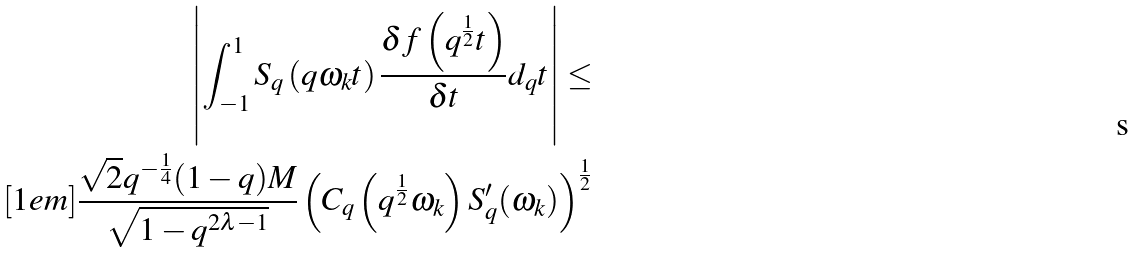Convert formula to latex. <formula><loc_0><loc_0><loc_500><loc_500>\left | \int _ { - 1 } ^ { 1 } S _ { q } \left ( q \omega _ { k } t \right ) \frac { \delta f \left ( q ^ { \frac { 1 } { 2 } } t \right ) } { \delta t } d _ { q } t \right | \leq \\ [ 1 e m ] \frac { \sqrt { 2 } q ^ { - \frac { 1 } { 4 } } ( 1 - q ) M } { \sqrt { 1 - q ^ { 2 \lambda - 1 } } } \left ( C _ { q } \left ( q ^ { \frac { 1 } { 2 } } \omega _ { k } \right ) S _ { q } ^ { \prime } ( \omega _ { k } ) \right ) ^ { \frac { 1 } { 2 } }</formula> 